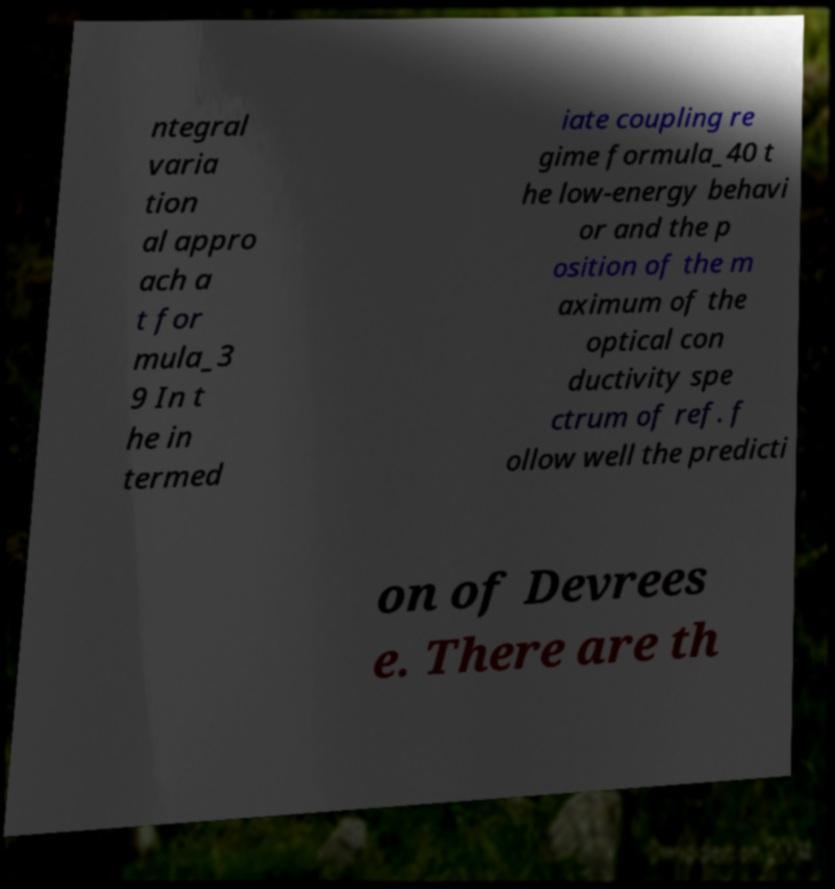Could you assist in decoding the text presented in this image and type it out clearly? ntegral varia tion al appro ach a t for mula_3 9 In t he in termed iate coupling re gime formula_40 t he low-energy behavi or and the p osition of the m aximum of the optical con ductivity spe ctrum of ref. f ollow well the predicti on of Devrees e. There are th 